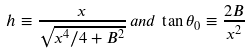Convert formula to latex. <formula><loc_0><loc_0><loc_500><loc_500>h \equiv \frac { x } { \sqrt { x ^ { 4 } / 4 + B ^ { 2 } } } \, a n d \, \tan \theta _ { 0 } \equiv \frac { 2 B } { x ^ { 2 } }</formula> 